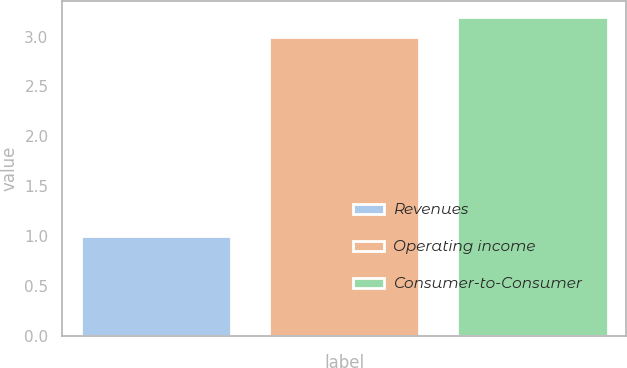Convert chart. <chart><loc_0><loc_0><loc_500><loc_500><bar_chart><fcel>Revenues<fcel>Operating income<fcel>Consumer-to-Consumer<nl><fcel>1<fcel>3<fcel>3.2<nl></chart> 